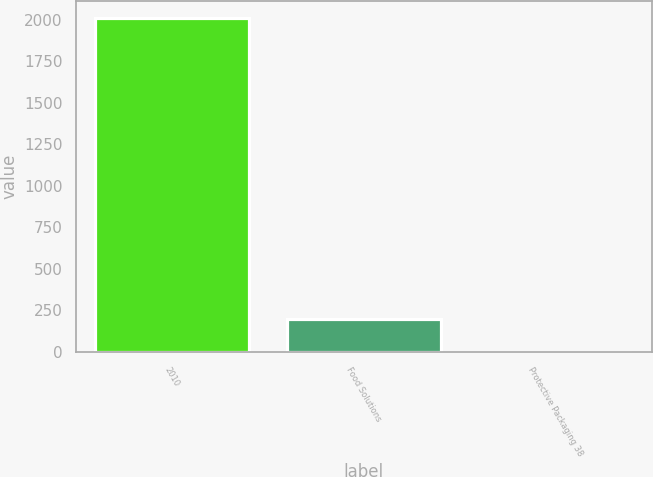<chart> <loc_0><loc_0><loc_500><loc_500><bar_chart><fcel>2010<fcel>Food Solutions<fcel>Protective Packaging 38<nl><fcel>2009<fcel>200.99<fcel>0.1<nl></chart> 